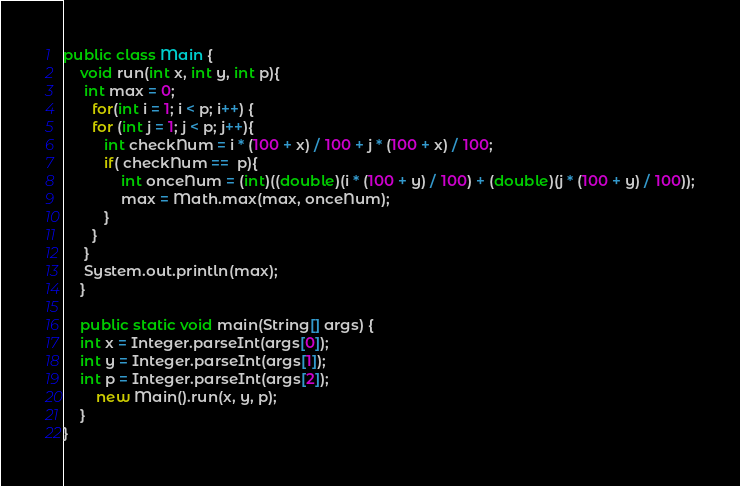<code> <loc_0><loc_0><loc_500><loc_500><_Java_>public class Main {
	void run(int x, int y, int p){
     int max = 0;
	   for(int i = 1; i < p; i++) {
       for (int j = 1; j < p; j++){
          int checkNum = i * (100 + x) / 100 + j * (100 + x) / 100;
          if( checkNum ==  p){
              int onceNum = (int)((double)(i * (100 + y) / 100) + (double)(j * (100 + y) / 100));
              max = Math.max(max, onceNum);
          }
       }
     }
     System.out.println(max);
	}

	public static void main(String[] args) {
    int x = Integer.parseInt(args[0]);
    int y = Integer.parseInt(args[1]);
    int p = Integer.parseInt(args[2]);
		new Main().run(x, y, p);
	}
}</code> 